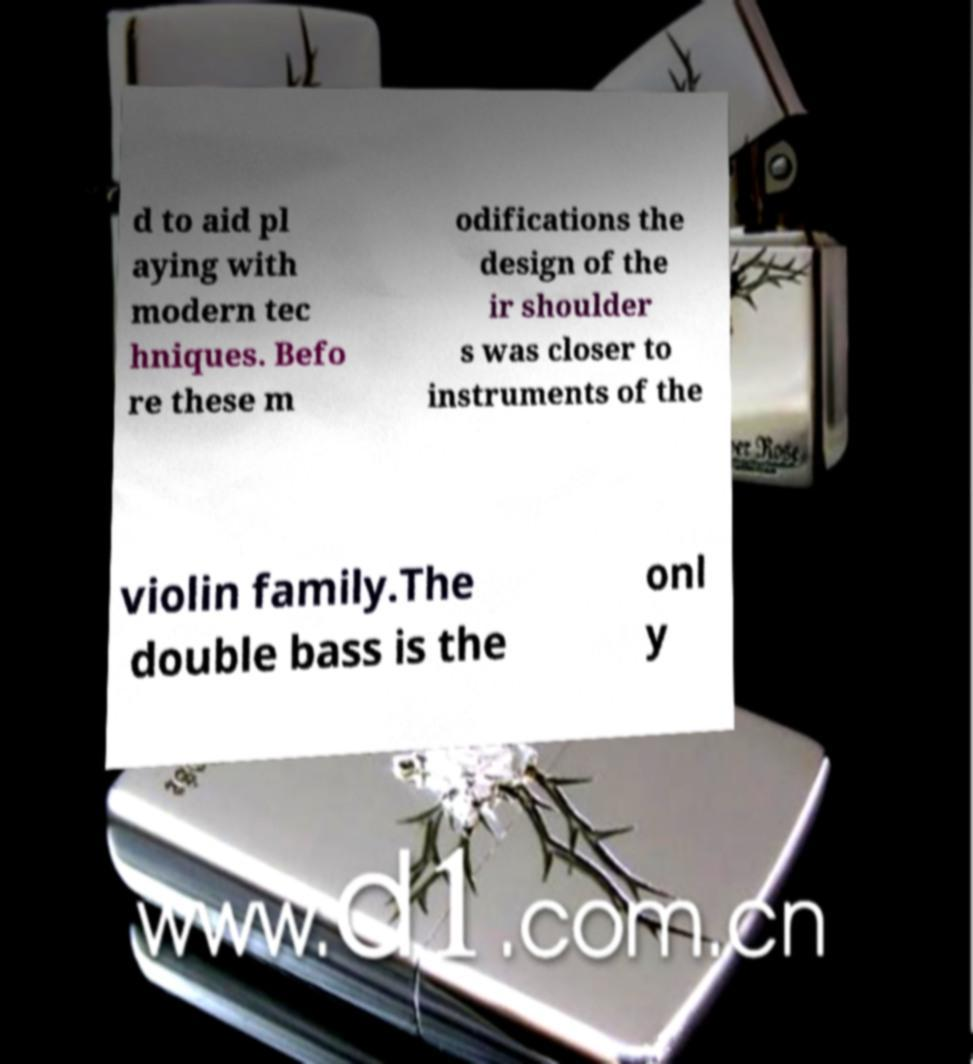For documentation purposes, I need the text within this image transcribed. Could you provide that? d to aid pl aying with modern tec hniques. Befo re these m odifications the design of the ir shoulder s was closer to instruments of the violin family.The double bass is the onl y 